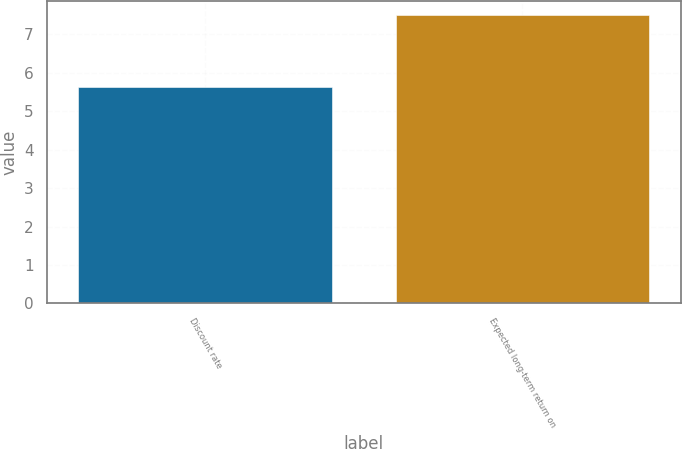Convert chart to OTSL. <chart><loc_0><loc_0><loc_500><loc_500><bar_chart><fcel>Discount rate<fcel>Expected long-term return on<nl><fcel>5.62<fcel>7.5<nl></chart> 